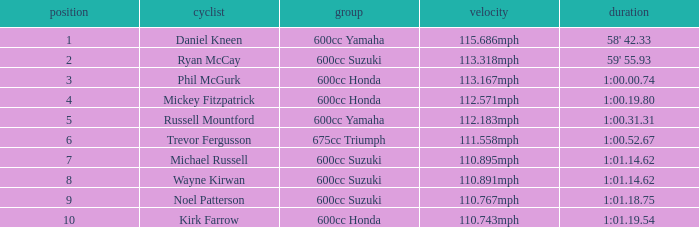How many ranks have 1:01.14.62 as the time, with michael russell as the rider? 1.0. 